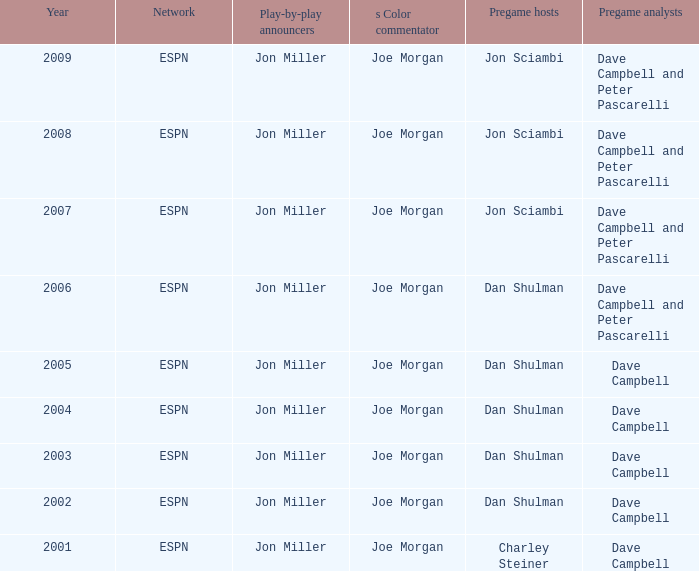Parse the full table. {'header': ['Year', 'Network', 'Play-by-play announcers', 's Color commentator', 'Pregame hosts', 'Pregame analysts'], 'rows': [['2009', 'ESPN', 'Jon Miller', 'Joe Morgan', 'Jon Sciambi', 'Dave Campbell and Peter Pascarelli'], ['2008', 'ESPN', 'Jon Miller', 'Joe Morgan', 'Jon Sciambi', 'Dave Campbell and Peter Pascarelli'], ['2007', 'ESPN', 'Jon Miller', 'Joe Morgan', 'Jon Sciambi', 'Dave Campbell and Peter Pascarelli'], ['2006', 'ESPN', 'Jon Miller', 'Joe Morgan', 'Dan Shulman', 'Dave Campbell and Peter Pascarelli'], ['2005', 'ESPN', 'Jon Miller', 'Joe Morgan', 'Dan Shulman', 'Dave Campbell'], ['2004', 'ESPN', 'Jon Miller', 'Joe Morgan', 'Dan Shulman', 'Dave Campbell'], ['2003', 'ESPN', 'Jon Miller', 'Joe Morgan', 'Dan Shulman', 'Dave Campbell'], ['2002', 'ESPN', 'Jon Miller', 'Joe Morgan', 'Dan Shulman', 'Dave Campbell'], ['2001', 'ESPN', 'Jon Miller', 'Joe Morgan', 'Charley Steiner', 'Dave Campbell']]} Who is the s color commentator when the pregame host is jon sciambi? Joe Morgan, Joe Morgan, Joe Morgan. 